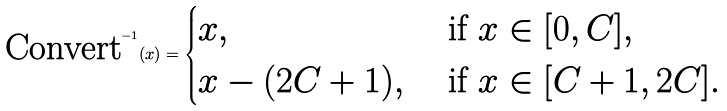Convert formula to latex. <formula><loc_0><loc_0><loc_500><loc_500>\text {Convert} ^ { - 1 } ( x ) = \begin{cases} x , & \text { if } x \in [ 0 , C ] , \\ x - ( 2 C + 1 ) , & \text { if } x \in [ C + 1 , 2 C ] . \end{cases}</formula> 